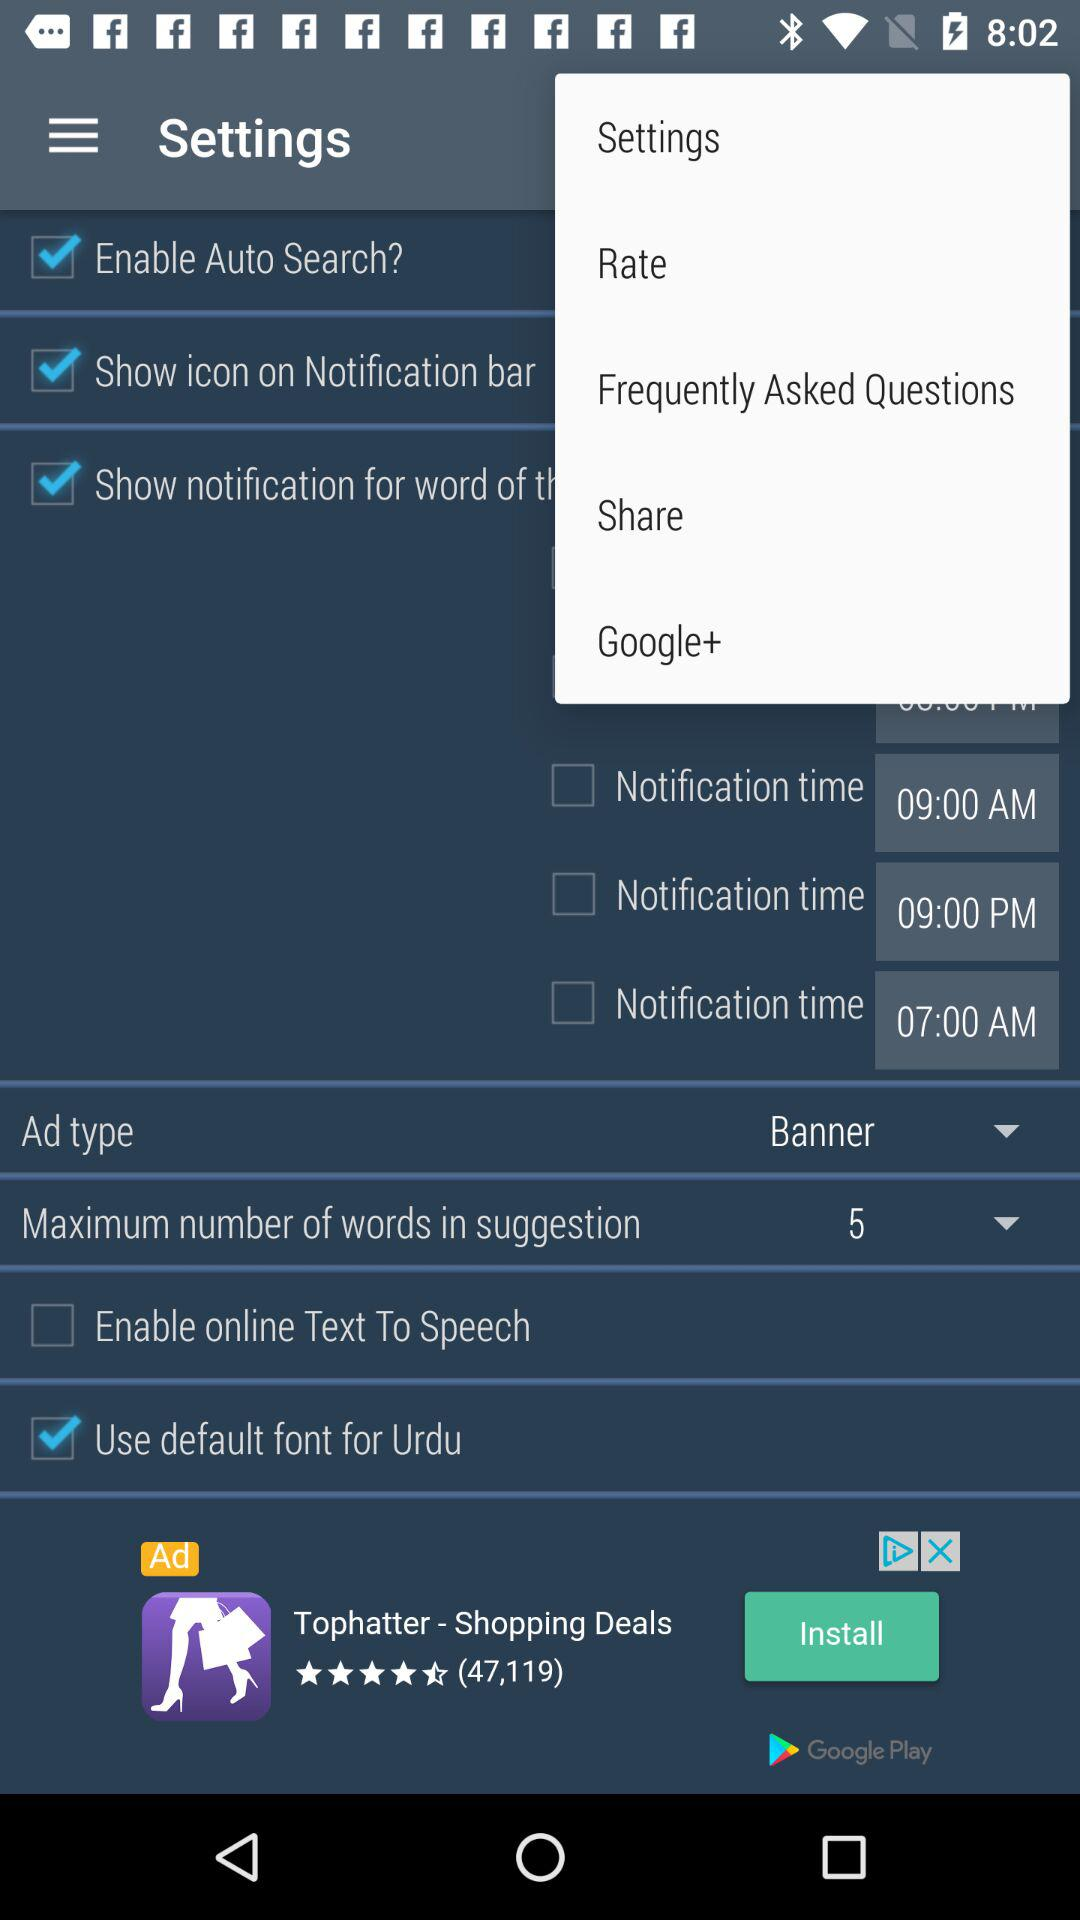Is "Enable Auto Search?" checked or unchecked?
Answer the question using a single word or phrase. It is "checked". 